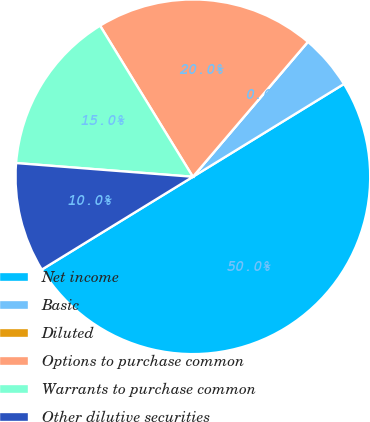Convert chart to OTSL. <chart><loc_0><loc_0><loc_500><loc_500><pie_chart><fcel>Net income<fcel>Basic<fcel>Diluted<fcel>Options to purchase common<fcel>Warrants to purchase common<fcel>Other dilutive securities<nl><fcel>50.0%<fcel>5.0%<fcel>0.0%<fcel>20.0%<fcel>15.0%<fcel>10.0%<nl></chart> 